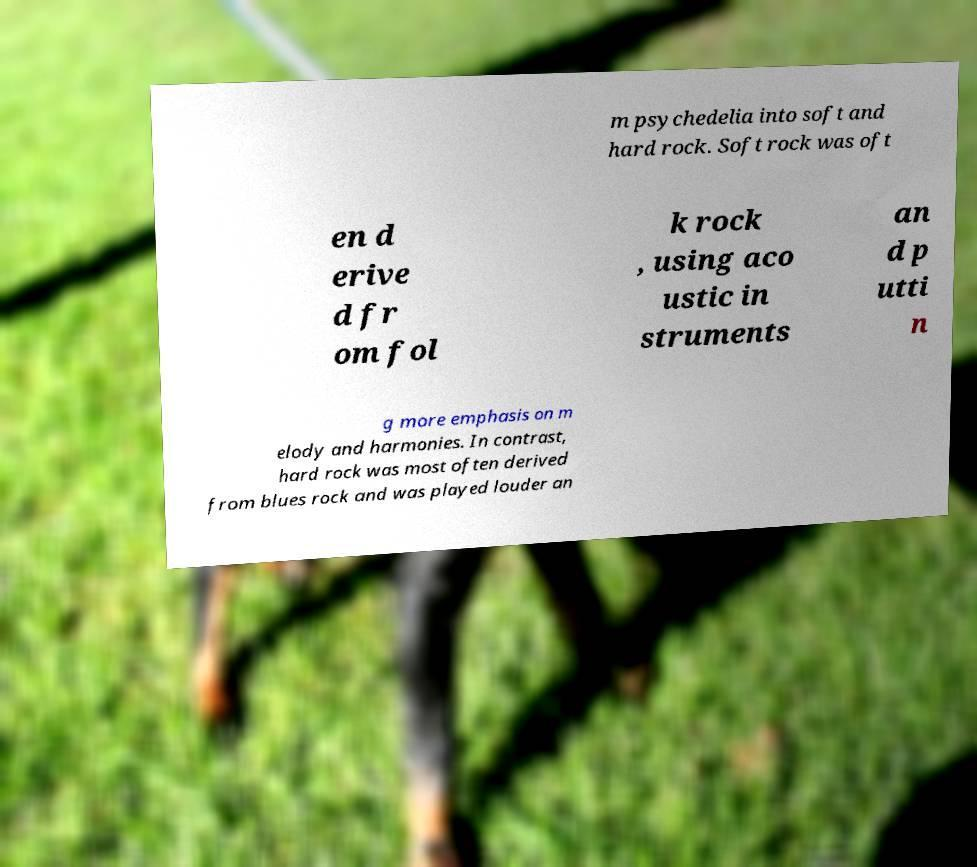What messages or text are displayed in this image? I need them in a readable, typed format. m psychedelia into soft and hard rock. Soft rock was oft en d erive d fr om fol k rock , using aco ustic in struments an d p utti n g more emphasis on m elody and harmonies. In contrast, hard rock was most often derived from blues rock and was played louder an 